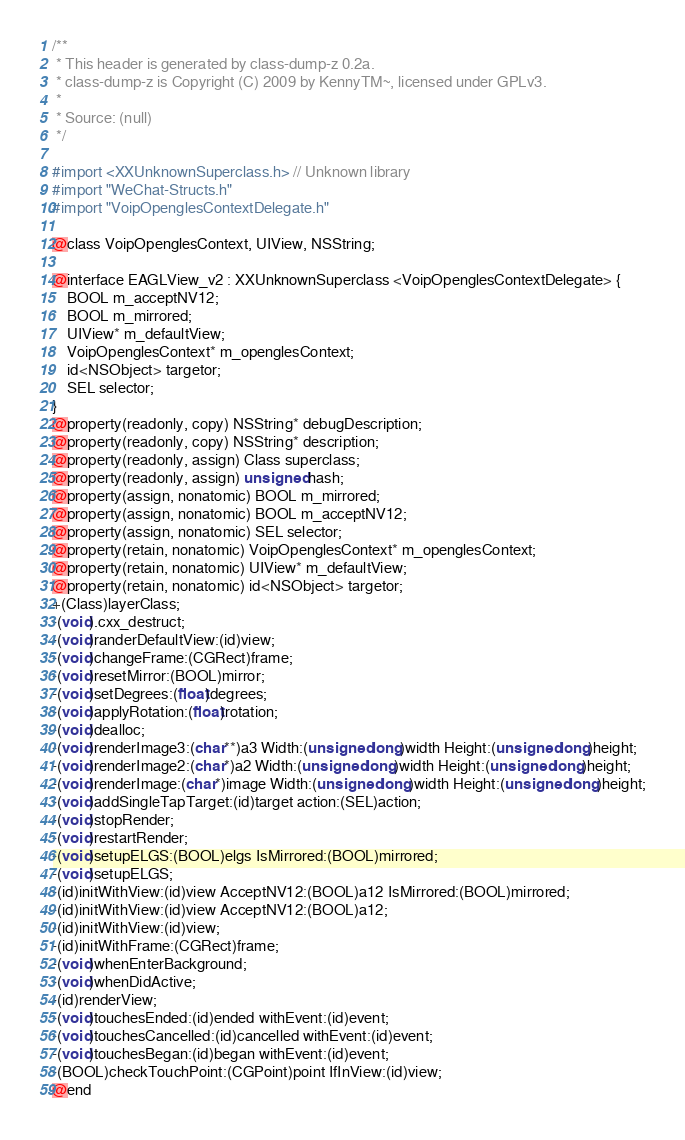Convert code to text. <code><loc_0><loc_0><loc_500><loc_500><_C_>/**
 * This header is generated by class-dump-z 0.2a.
 * class-dump-z is Copyright (C) 2009 by KennyTM~, licensed under GPLv3.
 *
 * Source: (null)
 */

#import <XXUnknownSuperclass.h> // Unknown library
#import "WeChat-Structs.h"
#import "VoipOpenglesContextDelegate.h"

@class VoipOpenglesContext, UIView, NSString;

@interface EAGLView_v2 : XXUnknownSuperclass <VoipOpenglesContextDelegate> {
	BOOL m_acceptNV12;
	BOOL m_mirrored;
	UIView* m_defaultView;
	VoipOpenglesContext* m_openglesContext;
	id<NSObject> targetor;
	SEL selector;
}
@property(readonly, copy) NSString* debugDescription;
@property(readonly, copy) NSString* description;
@property(readonly, assign) Class superclass;
@property(readonly, assign) unsigned hash;
@property(assign, nonatomic) BOOL m_mirrored;
@property(assign, nonatomic) BOOL m_acceptNV12;
@property(assign, nonatomic) SEL selector;
@property(retain, nonatomic) VoipOpenglesContext* m_openglesContext;
@property(retain, nonatomic) UIView* m_defaultView;
@property(retain, nonatomic) id<NSObject> targetor;
+(Class)layerClass;
-(void).cxx_destruct;
-(void)randerDefaultView:(id)view;
-(void)changeFrame:(CGRect)frame;
-(void)resetMirror:(BOOL)mirror;
-(void)setDegrees:(float)degrees;
-(void)applyRotation:(float)rotation;
-(void)dealloc;
-(void)renderImage3:(char**)a3 Width:(unsigned long)width Height:(unsigned long)height;
-(void)renderImage2:(char*)a2 Width:(unsigned long)width Height:(unsigned long)height;
-(void)renderImage:(char*)image Width:(unsigned long)width Height:(unsigned long)height;
-(void)addSingleTapTarget:(id)target action:(SEL)action;
-(void)stopRender;
-(void)restartRender;
-(void)setupELGS:(BOOL)elgs IsMirrored:(BOOL)mirrored;
-(void)setupELGS;
-(id)initWithView:(id)view AcceptNV12:(BOOL)a12 IsMirrored:(BOOL)mirrored;
-(id)initWithView:(id)view AcceptNV12:(BOOL)a12;
-(id)initWithView:(id)view;
-(id)initWithFrame:(CGRect)frame;
-(void)whenEnterBackground;
-(void)whenDidActive;
-(id)renderView;
-(void)touchesEnded:(id)ended withEvent:(id)event;
-(void)touchesCancelled:(id)cancelled withEvent:(id)event;
-(void)touchesBegan:(id)began withEvent:(id)event;
-(BOOL)checkTouchPoint:(CGPoint)point IfInView:(id)view;
@end

</code> 